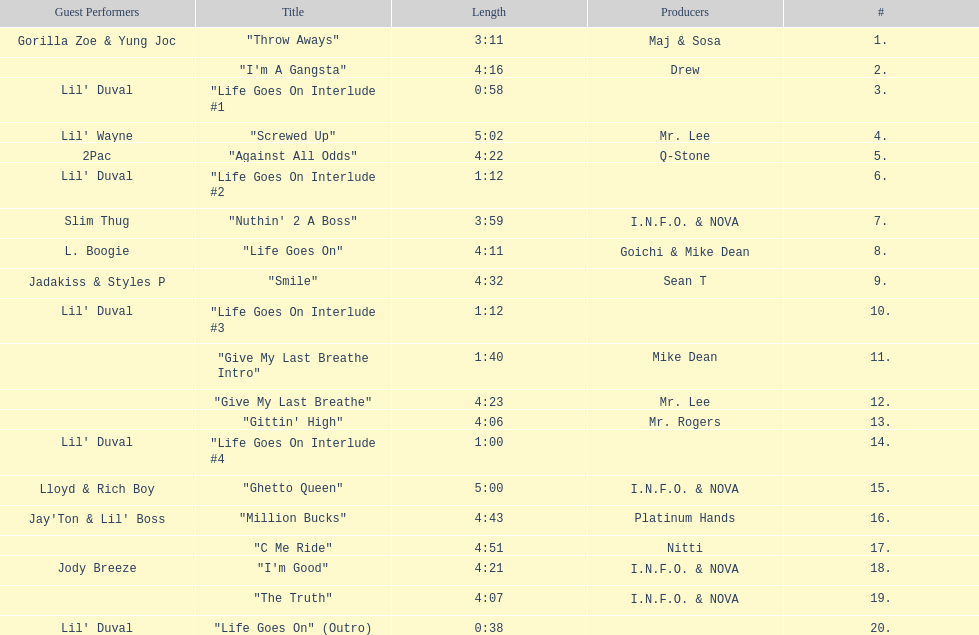Which tracks feature the same producer(s) in consecutive order on this album? "I'm Good", "The Truth". 